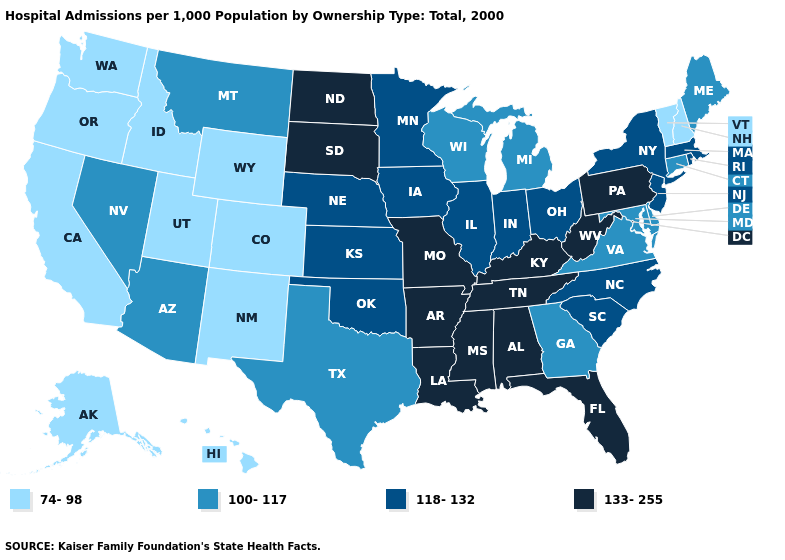Among the states that border Virginia , does Maryland have the highest value?
Concise answer only. No. Name the states that have a value in the range 133-255?
Keep it brief. Alabama, Arkansas, Florida, Kentucky, Louisiana, Mississippi, Missouri, North Dakota, Pennsylvania, South Dakota, Tennessee, West Virginia. Name the states that have a value in the range 118-132?
Answer briefly. Illinois, Indiana, Iowa, Kansas, Massachusetts, Minnesota, Nebraska, New Jersey, New York, North Carolina, Ohio, Oklahoma, Rhode Island, South Carolina. Does Virginia have the highest value in the South?
Give a very brief answer. No. Does the map have missing data?
Give a very brief answer. No. What is the value of Virginia?
Answer briefly. 100-117. What is the value of West Virginia?
Short answer required. 133-255. Does Illinois have the lowest value in the USA?
Be succinct. No. Among the states that border Pennsylvania , does West Virginia have the lowest value?
Concise answer only. No. Which states have the highest value in the USA?
Answer briefly. Alabama, Arkansas, Florida, Kentucky, Louisiana, Mississippi, Missouri, North Dakota, Pennsylvania, South Dakota, Tennessee, West Virginia. What is the value of New Hampshire?
Give a very brief answer. 74-98. Name the states that have a value in the range 118-132?
Quick response, please. Illinois, Indiana, Iowa, Kansas, Massachusetts, Minnesota, Nebraska, New Jersey, New York, North Carolina, Ohio, Oklahoma, Rhode Island, South Carolina. Does North Carolina have the same value as Oregon?
Be succinct. No. Does Nebraska have the lowest value in the USA?
Keep it brief. No. Which states have the lowest value in the USA?
Write a very short answer. Alaska, California, Colorado, Hawaii, Idaho, New Hampshire, New Mexico, Oregon, Utah, Vermont, Washington, Wyoming. 